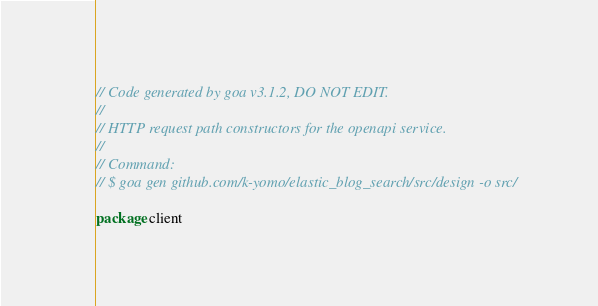Convert code to text. <code><loc_0><loc_0><loc_500><loc_500><_Go_>// Code generated by goa v3.1.2, DO NOT EDIT.
//
// HTTP request path constructors for the openapi service.
//
// Command:
// $ goa gen github.com/k-yomo/elastic_blog_search/src/design -o src/

package client
</code> 